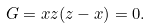<formula> <loc_0><loc_0><loc_500><loc_500>G = x z ( z - x ) = 0 .</formula> 